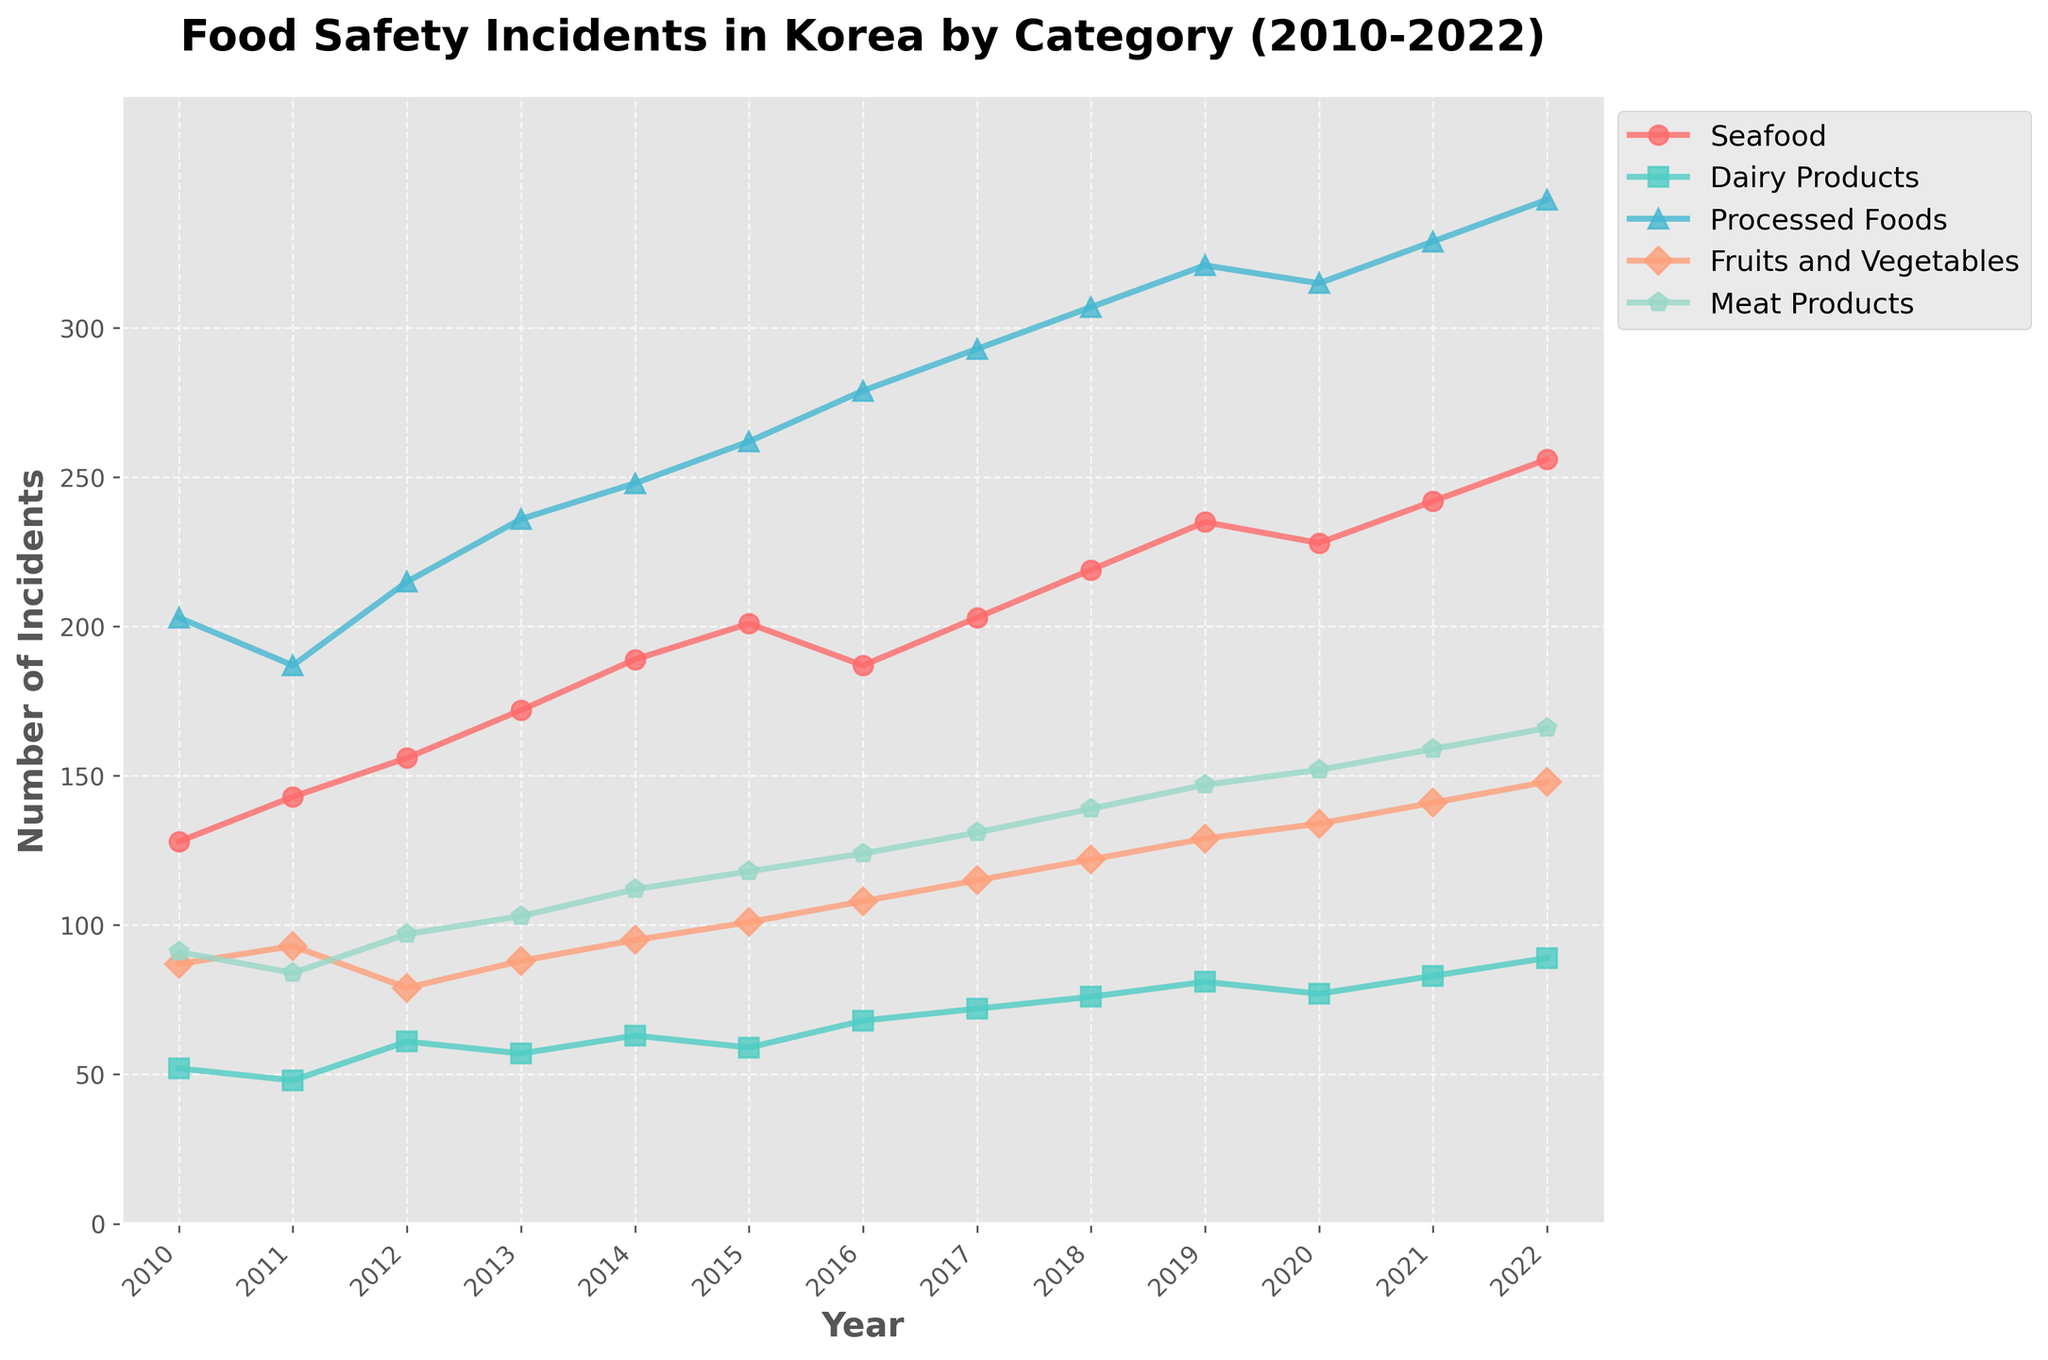What has been the trend in the number of incidents for Processed Foods over the years? The trend shows an overall increase in the number of incidents for Processed Foods from 2010 to 2022. This is evidenced by the upward sloping line representing Processed Foods in the chart.
Answer: Increasing Comparing Meat Products and Dairy Products, which category had more incidents reported in 2016? In 2016, the line for Meat Products is higher than the line for Dairy Products on the vertical scale representing the number of incidents. Thus, Meat Products had more incidents reported.
Answer: Meat Products Between which years did Seafood incidents see the highest jump in numbers? By examining the vertical distance between each year's data points for Seafood, the biggest jump is noticeable between 2018 and 2019. The line for Seafood steeply goes up by a larger margin here compared to other intervals.
Answer: 2018 to 2019 What is the difference in the number of incidents between Fruits and Vegetables and Meat Products in 2020? In 2020, the number of incidents for Fruits and Vegetables is 134 and for Meat Products is 152. Subtracting these values gives 152 - 134 = 18.
Answer: 18 Which year showed the highest number of Dairy Products incidents? The highest point for Dairy Products is in the year 2022 as it has the highest value on the vertical scale.
Answer: 2022 How many total incidents were reported in 2015 for all categories combined? In 2015, the numbers for each category are: Seafood (201), Dairy Products (59), Processed Foods (262), Fruits and Vegetables (101), and Meat Products (118). Summing these values, 201 + 59 + 262 + 101 + 118 = 741.
Answer: 741 Did the number of incidents for Seafood consistently increase every year? By following the line for Seafood, we can see that it does not consistently increase every year, particularly between 2015 and 2016, where there is a decrease.
Answer: No By how much did the number of incidents for Fruits and Vegetables increase from 2010 to 2022? The number of incidents for Fruits and Vegetables in 2010 was 87 and in 2022 it was 148. The increase is 148 - 87 = 61.
Answer: 61 Which food category saw the smallest increase in incidents from 2010 to 2022? By comparing the endpoints for each category in 2010 and 2022, Dairy Products showed the smallest increase from 52 incidents in 2010 to 89 in 2022.
Answer: Dairy Products 